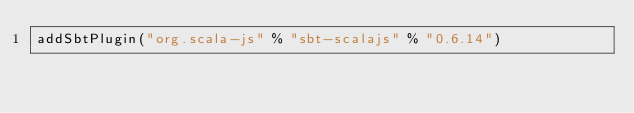Convert code to text. <code><loc_0><loc_0><loc_500><loc_500><_Scala_>addSbtPlugin("org.scala-js" % "sbt-scalajs" % "0.6.14")</code> 